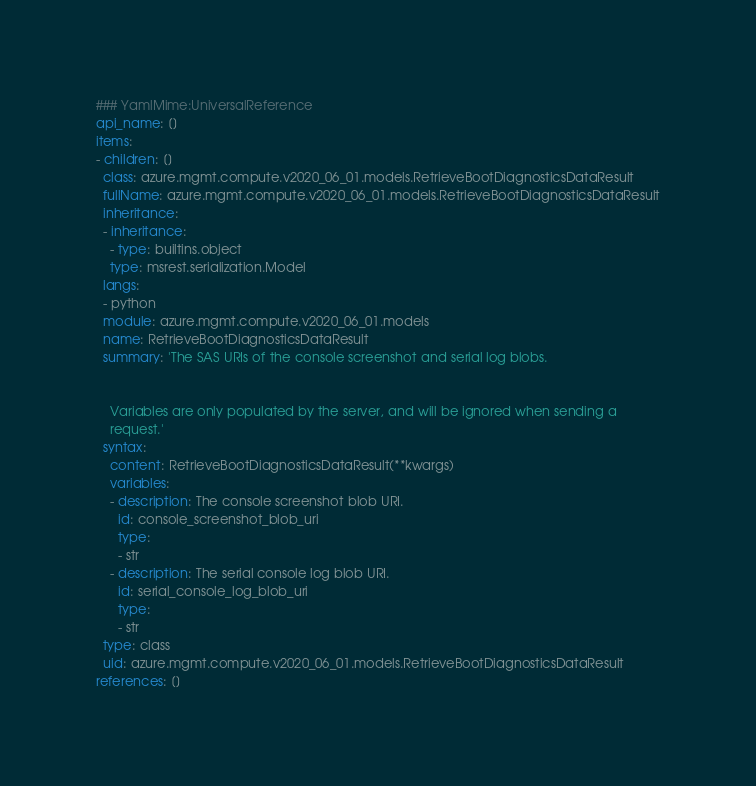<code> <loc_0><loc_0><loc_500><loc_500><_YAML_>### YamlMime:UniversalReference
api_name: []
items:
- children: []
  class: azure.mgmt.compute.v2020_06_01.models.RetrieveBootDiagnosticsDataResult
  fullName: azure.mgmt.compute.v2020_06_01.models.RetrieveBootDiagnosticsDataResult
  inheritance:
  - inheritance:
    - type: builtins.object
    type: msrest.serialization.Model
  langs:
  - python
  module: azure.mgmt.compute.v2020_06_01.models
  name: RetrieveBootDiagnosticsDataResult
  summary: 'The SAS URIs of the console screenshot and serial log blobs.


    Variables are only populated by the server, and will be ignored when sending a
    request.'
  syntax:
    content: RetrieveBootDiagnosticsDataResult(**kwargs)
    variables:
    - description: The console screenshot blob URI.
      id: console_screenshot_blob_uri
      type:
      - str
    - description: The serial console log blob URI.
      id: serial_console_log_blob_uri
      type:
      - str
  type: class
  uid: azure.mgmt.compute.v2020_06_01.models.RetrieveBootDiagnosticsDataResult
references: []
</code> 